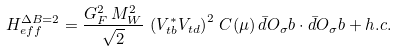<formula> <loc_0><loc_0><loc_500><loc_500>H ^ { \Delta B = 2 } _ { e f f } = \frac { G ^ { 2 } _ { F } \, M ^ { 2 } _ { W } } { \sqrt { 2 } } \, \left ( V ^ { * } _ { t b } V _ { t d } \right ) ^ { 2 } \, C ( \mu ) \, \bar { d } O _ { \sigma } b \cdot \bar { d } O _ { \sigma } b + h . c .</formula> 